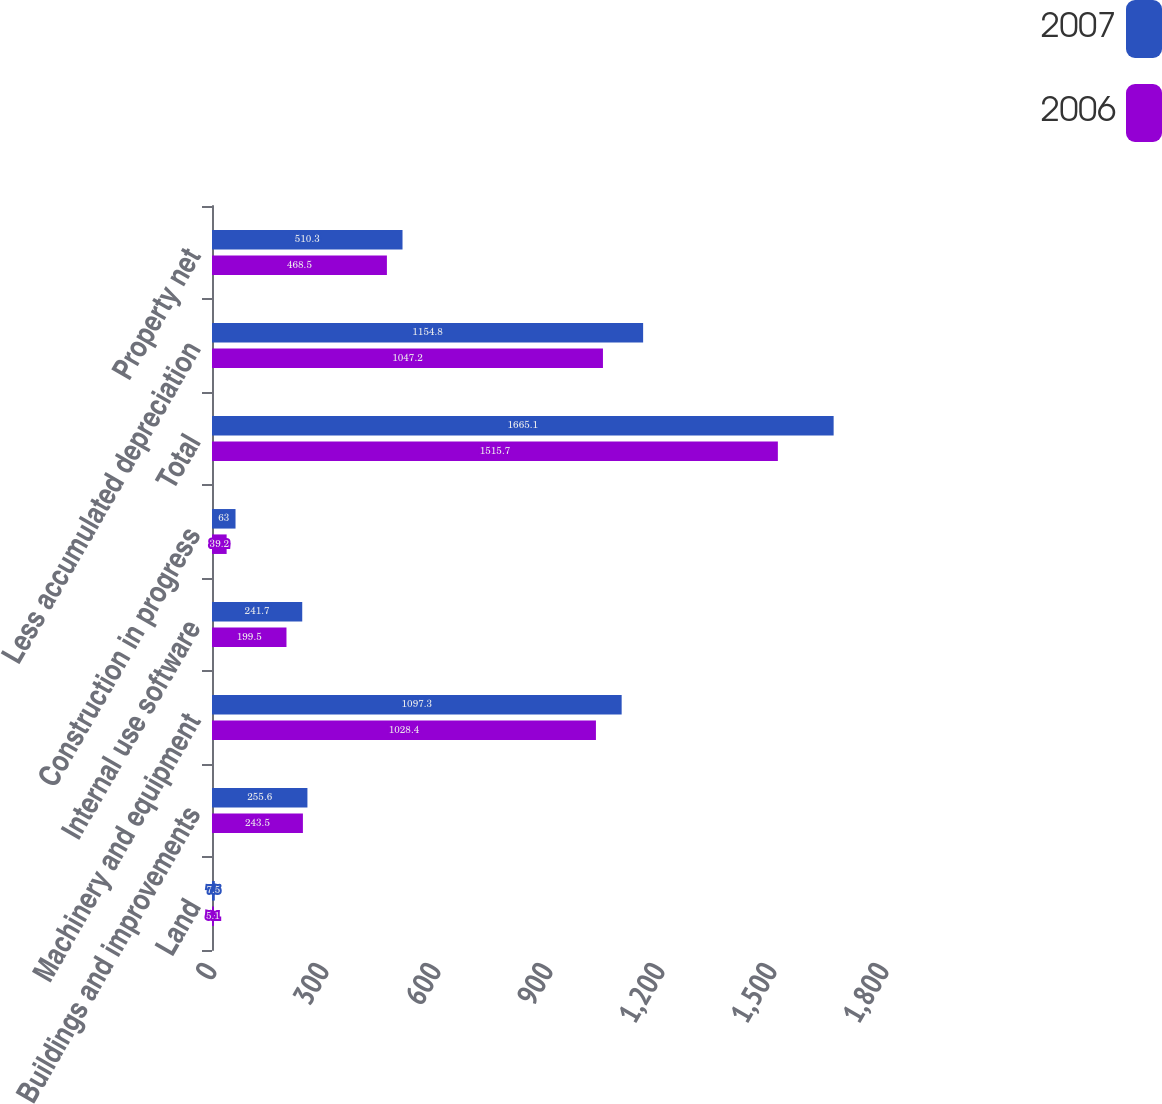Convert chart. <chart><loc_0><loc_0><loc_500><loc_500><stacked_bar_chart><ecel><fcel>Land<fcel>Buildings and improvements<fcel>Machinery and equipment<fcel>Internal use software<fcel>Construction in progress<fcel>Total<fcel>Less accumulated depreciation<fcel>Property net<nl><fcel>2007<fcel>7.5<fcel>255.6<fcel>1097.3<fcel>241.7<fcel>63<fcel>1665.1<fcel>1154.8<fcel>510.3<nl><fcel>2006<fcel>5.1<fcel>243.5<fcel>1028.4<fcel>199.5<fcel>39.2<fcel>1515.7<fcel>1047.2<fcel>468.5<nl></chart> 